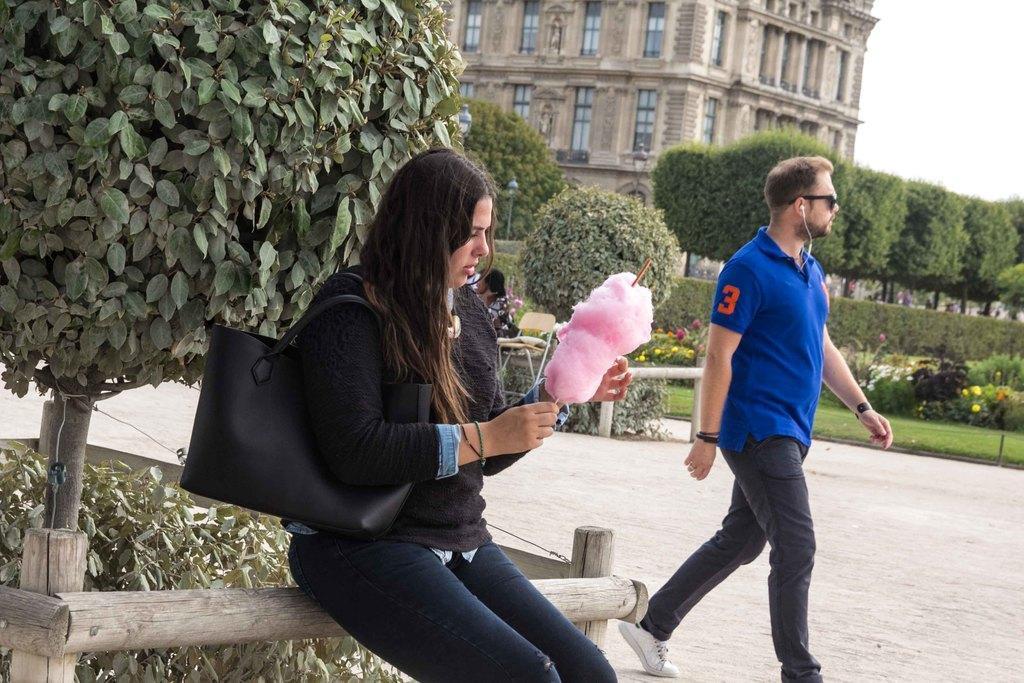Can you describe this image briefly? In this image in the front there is a woman sitting and holding a candy in her hand. In the center there is a man walking. In the background there are plants, flowers and there is grass on the ground and there are persons and there is a building. 